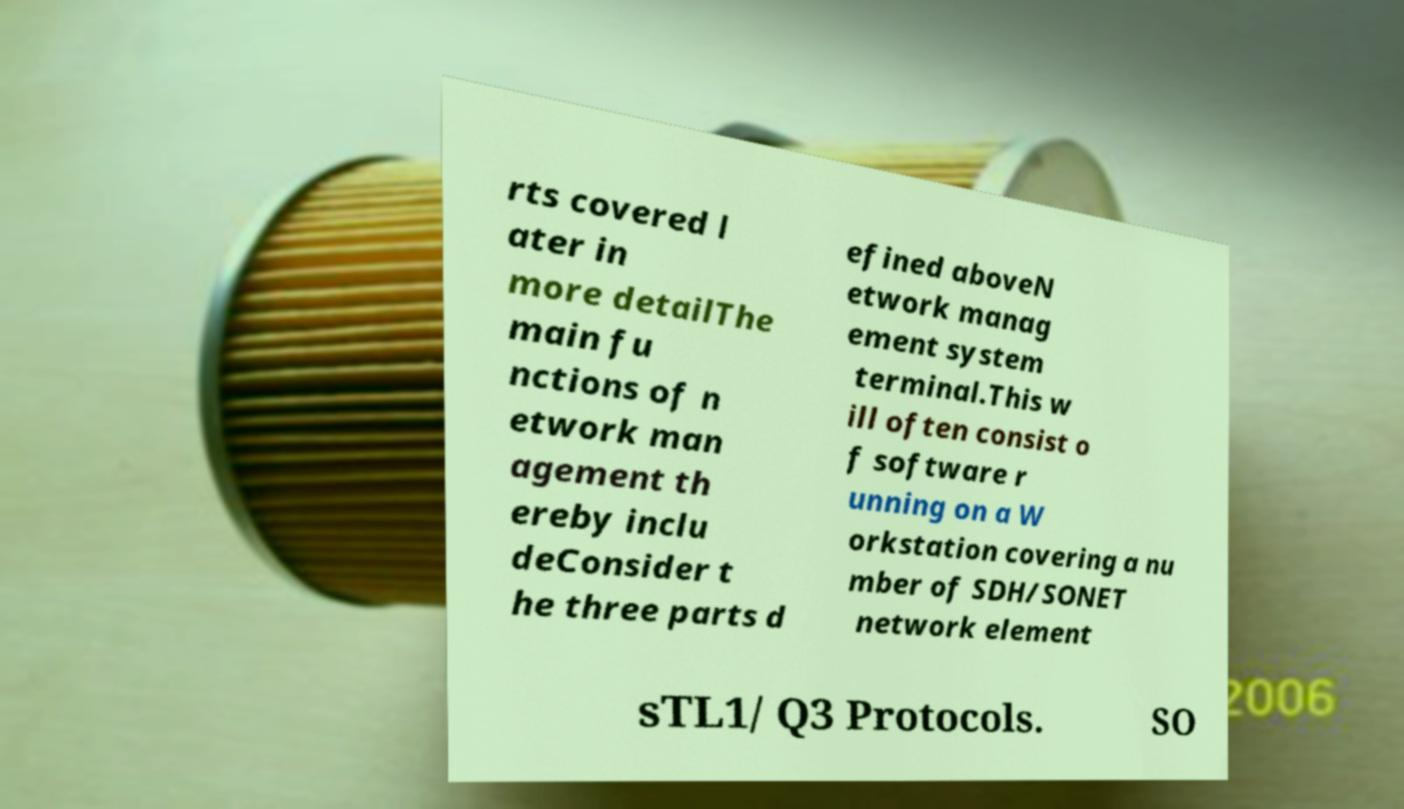Please identify and transcribe the text found in this image. rts covered l ater in more detailThe main fu nctions of n etwork man agement th ereby inclu deConsider t he three parts d efined aboveN etwork manag ement system terminal.This w ill often consist o f software r unning on a W orkstation covering a nu mber of SDH/SONET network element sTL1/ Q3 Protocols. SO 